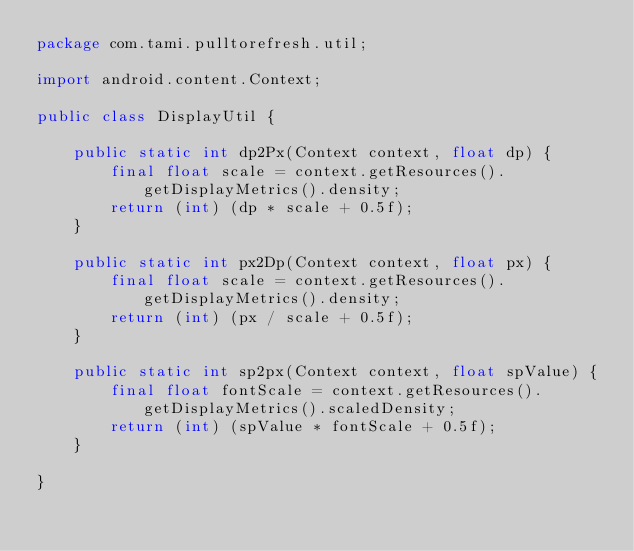Convert code to text. <code><loc_0><loc_0><loc_500><loc_500><_Java_>package com.tami.pulltorefresh.util;

import android.content.Context;

public class DisplayUtil {

    public static int dp2Px(Context context, float dp) {
        final float scale = context.getResources().getDisplayMetrics().density;
        return (int) (dp * scale + 0.5f);
    }

    public static int px2Dp(Context context, float px) {
        final float scale = context.getResources().getDisplayMetrics().density;
        return (int) (px / scale + 0.5f);
    }

    public static int sp2px(Context context, float spValue) {
        final float fontScale = context.getResources().getDisplayMetrics().scaledDensity;
        return (int) (spValue * fontScale + 0.5f);
    }

}
</code> 